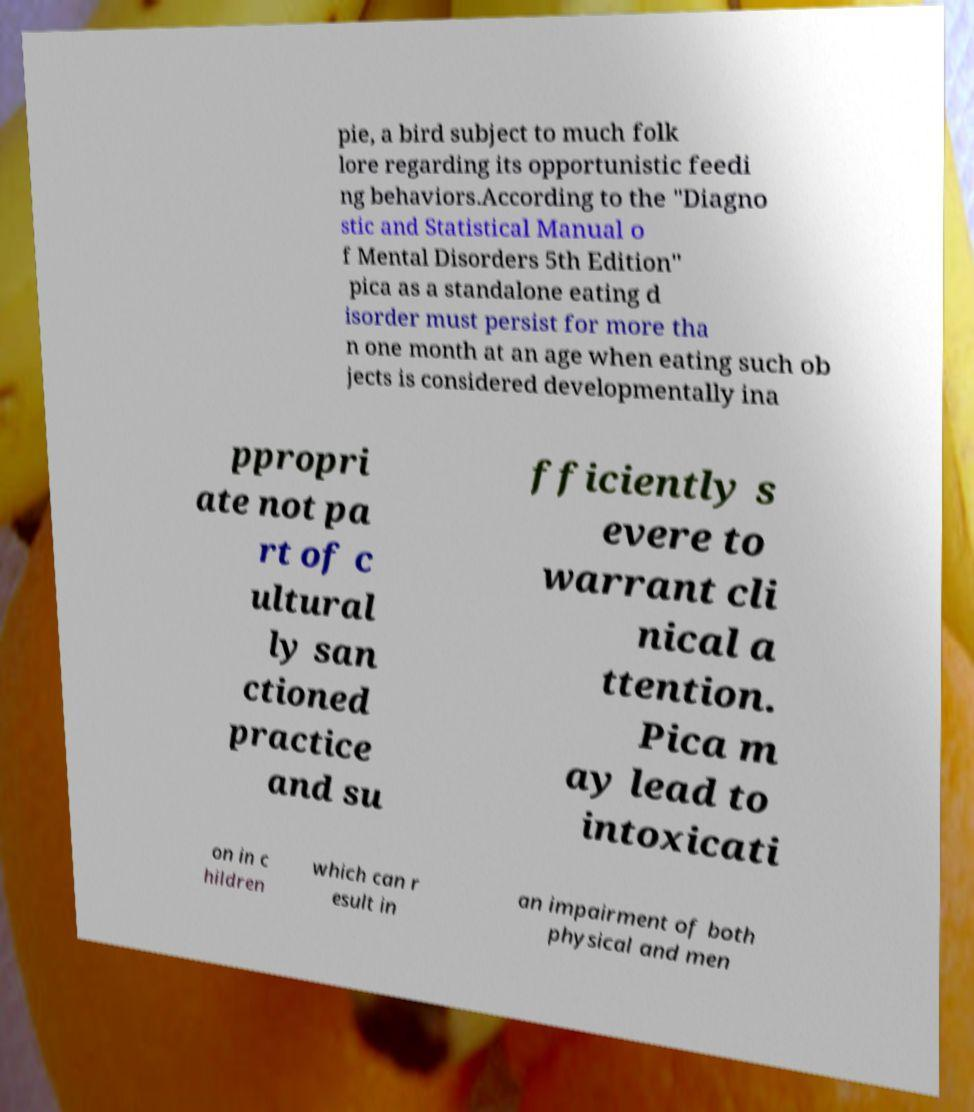For documentation purposes, I need the text within this image transcribed. Could you provide that? pie, a bird subject to much folk lore regarding its opportunistic feedi ng behaviors.According to the "Diagno stic and Statistical Manual o f Mental Disorders 5th Edition" pica as a standalone eating d isorder must persist for more tha n one month at an age when eating such ob jects is considered developmentally ina ppropri ate not pa rt of c ultural ly san ctioned practice and su fficiently s evere to warrant cli nical a ttention. Pica m ay lead to intoxicati on in c hildren which can r esult in an impairment of both physical and men 